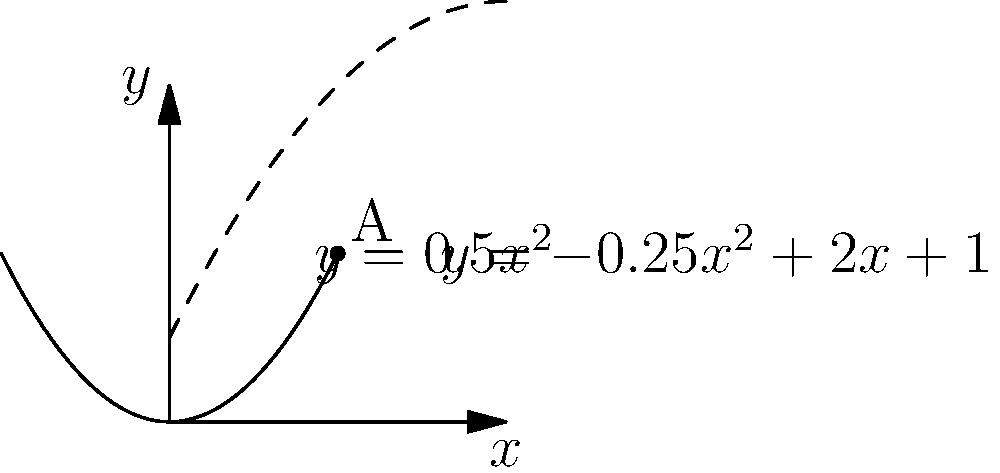In a high-speed racing scenario, you're approaching a complex turn represented by two polynomial functions: $y=0.5x^2$ and $y=-0.25x^2+2x+1$. The optimal racing line is often found where these curves intersect. At what point $(x,y)$ do these curves intersect, representing the ideal apex of your turn? To find the intersection point, we need to solve the equation:

$$0.5x^2 = -0.25x^2+2x+1$$

Step 1: Rearrange the equation
$$0.5x^2 + 0.25x^2 = 2x + 1$$
$$0.75x^2 = 2x + 1$$

Step 2: Subtract 2x and 1 from both sides
$$0.75x^2 - 2x - 1 = 0$$

Step 3: Multiply all terms by 4 to eliminate fractions
$$3x^2 - 8x - 4 = 0$$

Step 4: Use the quadratic formula $x = \frac{-b \pm \sqrt{b^2 - 4ac}}{2a}$
Where $a=3$, $b=-8$, and $c=-4$

$$x = \frac{8 \pm \sqrt{64 + 48}}{6} = \frac{8 \pm \sqrt{112}}{6}$$

Step 5: Simplify
$$x = \frac{8 \pm 2\sqrt{28}}{6} = \frac{4 \pm \sqrt{28}}{3}$$

Step 6: The positive solution is $x = \frac{4 + \sqrt{28}}{3} \approx 2$

Step 7: Calculate y by substituting x into either original equation
$$y = 0.5(2)^2 = 2$$

Therefore, the curves intersect at the point (2,2).
Answer: (2,2) 